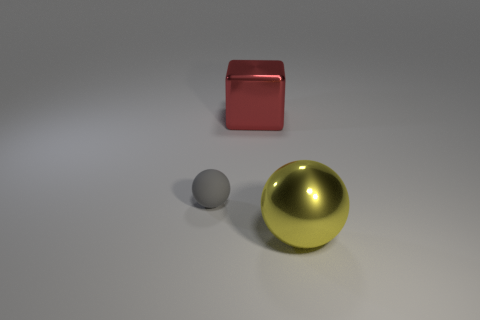Add 1 small rubber objects. How many objects exist? 4 Subtract all blocks. How many objects are left? 2 Add 3 metallic things. How many metallic things are left? 5 Add 2 big balls. How many big balls exist? 3 Subtract 0 blue cubes. How many objects are left? 3 Subtract all big shiny cubes. Subtract all yellow objects. How many objects are left? 1 